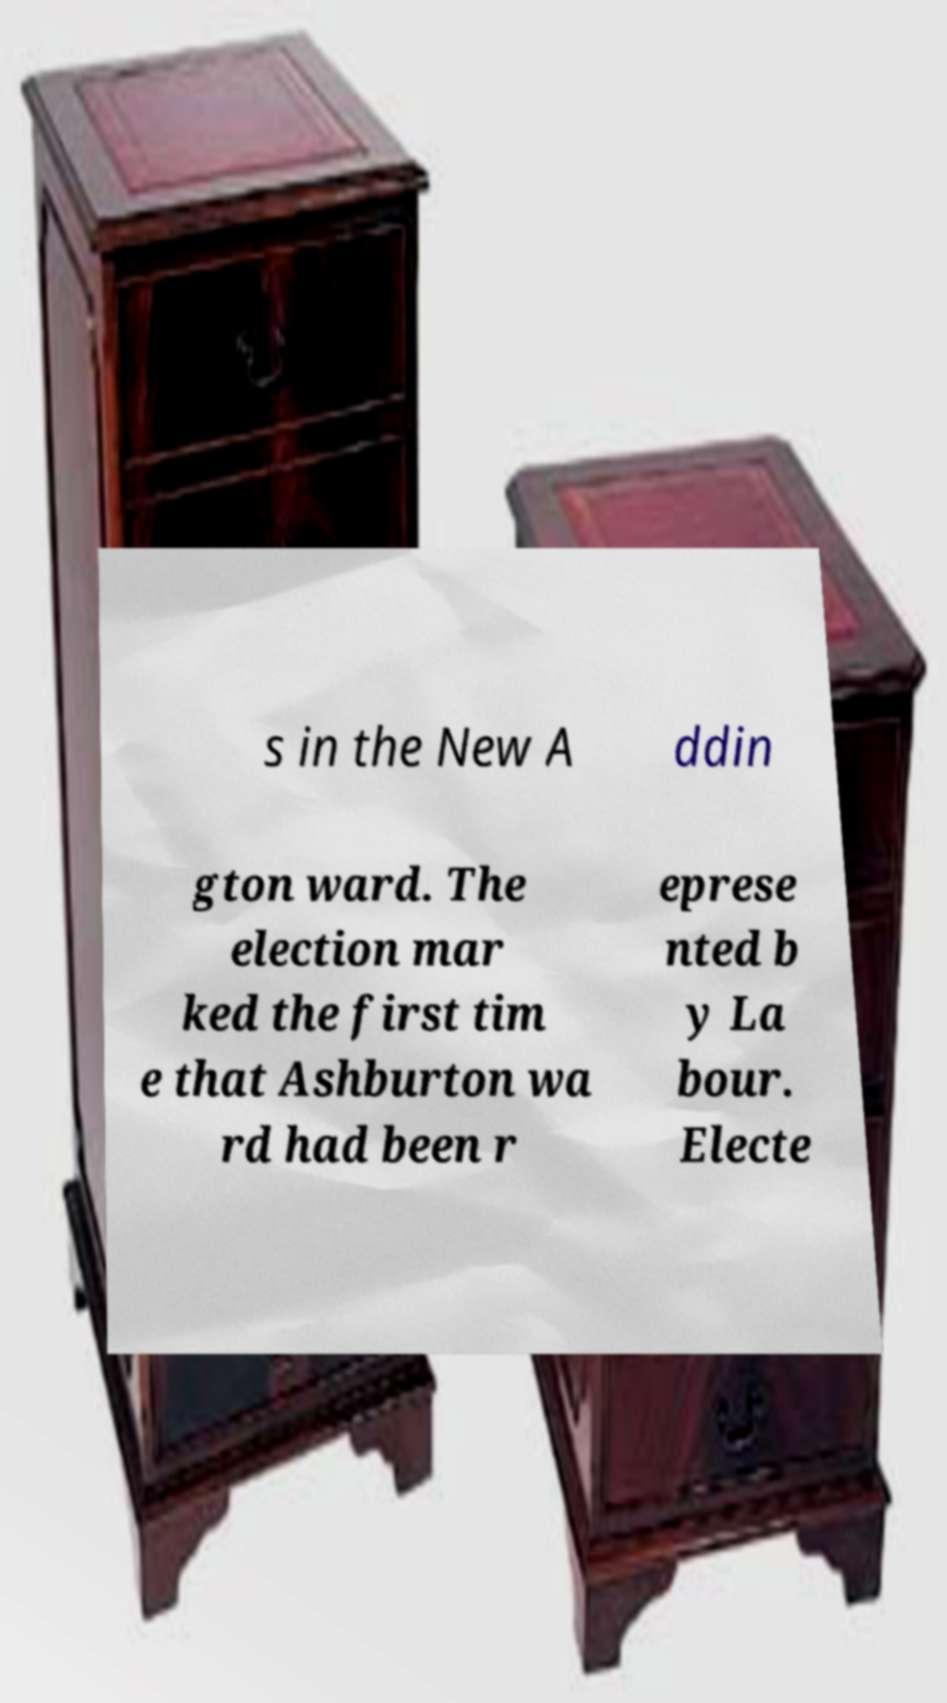There's text embedded in this image that I need extracted. Can you transcribe it verbatim? s in the New A ddin gton ward. The election mar ked the first tim e that Ashburton wa rd had been r eprese nted b y La bour. Electe 